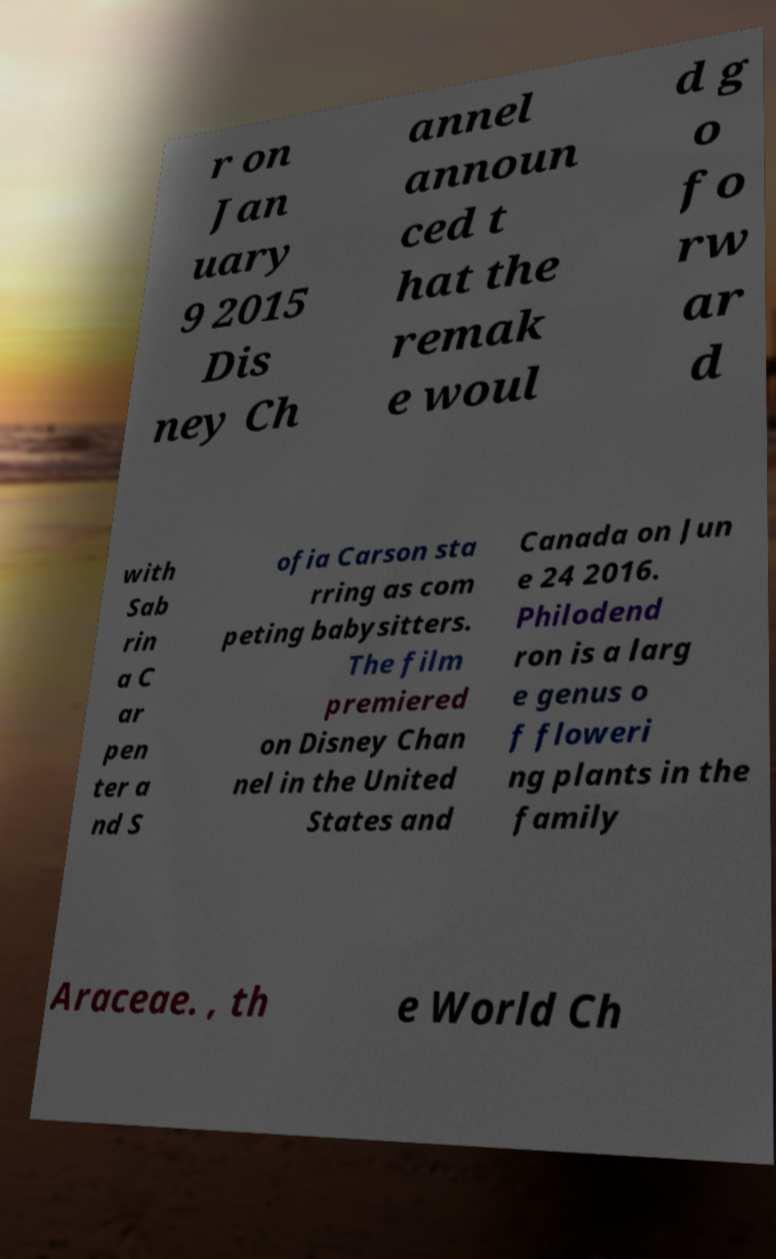Could you extract and type out the text from this image? r on Jan uary 9 2015 Dis ney Ch annel announ ced t hat the remak e woul d g o fo rw ar d with Sab rin a C ar pen ter a nd S ofia Carson sta rring as com peting babysitters. The film premiered on Disney Chan nel in the United States and Canada on Jun e 24 2016. Philodend ron is a larg e genus o f floweri ng plants in the family Araceae. , th e World Ch 